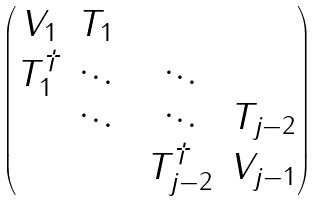<formula> <loc_0><loc_0><loc_500><loc_500>\begin{pmatrix} V _ { 1 } & T _ { 1 } \\ T _ { 1 } ^ { \dagger } & \ddots & & \ddots \\ & \ddots & & \ddots & T _ { j - 2 } \\ & & & T _ { j - 2 } ^ { \dagger } & V _ { j - 1 } \end{pmatrix}</formula> 